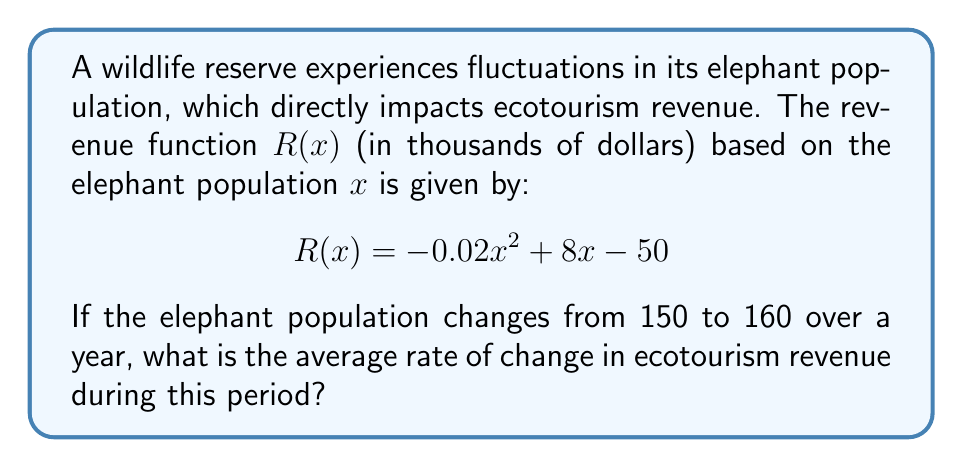Can you solve this math problem? To find the average rate of change in ecotourism revenue, we need to calculate the difference in revenue divided by the difference in population:

1) First, let's calculate the revenue for each population:
   
   For x = 150:
   $$R(150) = -0.02(150)^2 + 8(150) - 50 = -450 + 1200 - 50 = 700$$
   
   For x = 160:
   $$R(160) = -0.02(160)^2 + 8(160) - 50 = -512 + 1280 - 50 = 718$$

2) Now, we can calculate the average rate of change:
   
   $$\text{Average Rate of Change} = \frac{R(160) - R(150)}{160 - 150}$$
   
   $$= \frac{718 - 700}{10} = \frac{18}{10} = 1.8$$

3) Therefore, the average rate of change is 1.8 thousand dollars per elephant.
Answer: $1.8$ thousand dollars per elephant 